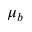<formula> <loc_0><loc_0><loc_500><loc_500>\mu _ { b }</formula> 